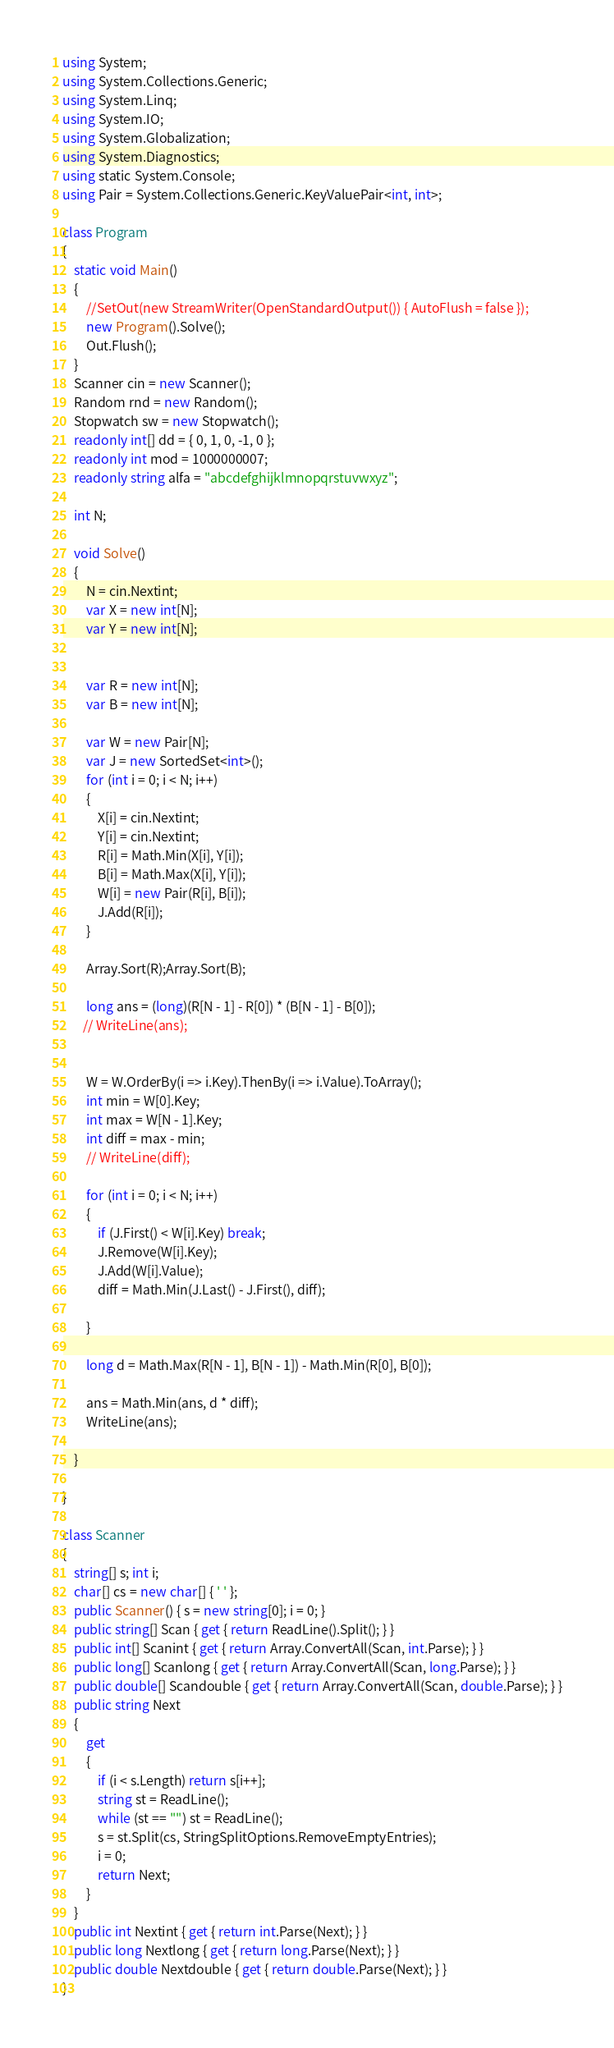Convert code to text. <code><loc_0><loc_0><loc_500><loc_500><_C#_>using System;
using System.Collections.Generic;
using System.Linq;
using System.IO;
using System.Globalization;
using System.Diagnostics;
using static System.Console;
using Pair = System.Collections.Generic.KeyValuePair<int, int>;

class Program
{
    static void Main()
    {
        //SetOut(new StreamWriter(OpenStandardOutput()) { AutoFlush = false });
        new Program().Solve();
        Out.Flush();
    }
    Scanner cin = new Scanner();
    Random rnd = new Random();
    Stopwatch sw = new Stopwatch();
    readonly int[] dd = { 0, 1, 0, -1, 0 };
    readonly int mod = 1000000007;
    readonly string alfa = "abcdefghijklmnopqrstuvwxyz";

    int N;

    void Solve()
    {
        N = cin.Nextint;
        var X = new int[N];
        var Y = new int[N];


        var R = new int[N];
        var B = new int[N];

        var W = new Pair[N];
        var J = new SortedSet<int>();
        for (int i = 0; i < N; i++)
        {
            X[i] = cin.Nextint;
            Y[i] = cin.Nextint;
            R[i] = Math.Min(X[i], Y[i]);
            B[i] = Math.Max(X[i], Y[i]);
            W[i] = new Pair(R[i], B[i]);
            J.Add(R[i]);
        }

        Array.Sort(R);Array.Sort(B);

        long ans = (long)(R[N - 1] - R[0]) * (B[N - 1] - B[0]);
       // WriteLine(ans);

     
        W = W.OrderBy(i => i.Key).ThenBy(i => i.Value).ToArray();
        int min = W[0].Key;
        int max = W[N - 1].Key;
        int diff = max - min;
        // WriteLine(diff);

        for (int i = 0; i < N; i++)
        {
            if (J.First() < W[i].Key) break;
            J.Remove(W[i].Key);
            J.Add(W[i].Value);
            diff = Math.Min(J.Last() - J.First(), diff);
        
        }

        long d = Math.Max(R[N - 1], B[N - 1]) - Math.Min(R[0], B[0]);

        ans = Math.Min(ans, d * diff);
        WriteLine(ans);

    }

}

class Scanner
{
    string[] s; int i;
    char[] cs = new char[] { ' ' };
    public Scanner() { s = new string[0]; i = 0; }
    public string[] Scan { get { return ReadLine().Split(); } }
    public int[] Scanint { get { return Array.ConvertAll(Scan, int.Parse); } }
    public long[] Scanlong { get { return Array.ConvertAll(Scan, long.Parse); } }
    public double[] Scandouble { get { return Array.ConvertAll(Scan, double.Parse); } }
    public string Next
    {
        get
        {
            if (i < s.Length) return s[i++];
            string st = ReadLine();
            while (st == "") st = ReadLine();
            s = st.Split(cs, StringSplitOptions.RemoveEmptyEntries);
            i = 0;
            return Next;
        }
    }
    public int Nextint { get { return int.Parse(Next); } }
    public long Nextlong { get { return long.Parse(Next); } }
    public double Nextdouble { get { return double.Parse(Next); } }
}</code> 